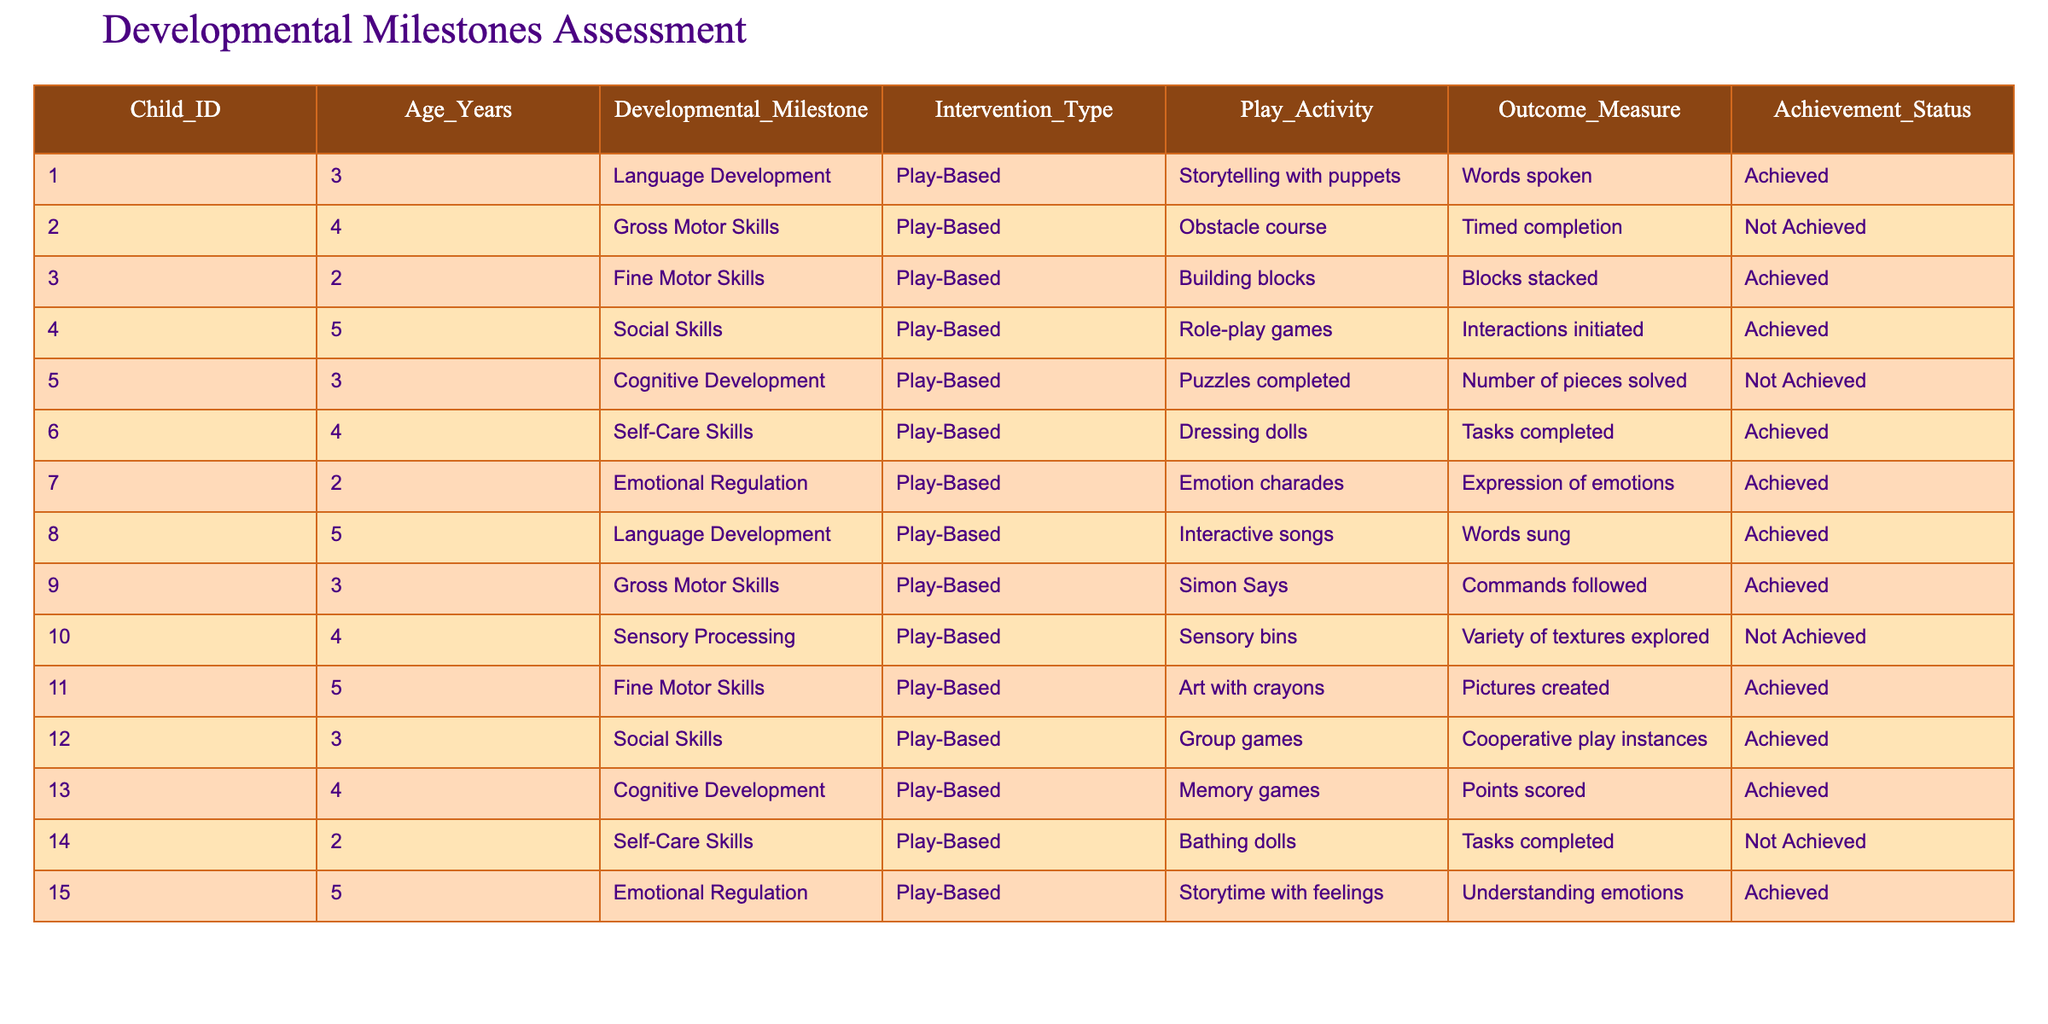What percentage of children achieved their developmental milestones? There are 15 children in the data, out of which 9 achieved their milestones. To find the percentage: (9/15) * 100 = 60%.
Answer: 60% Which age group had the highest number of children achieving their milestones? The age group of 5 years had the most achieved milestones: Children 004, 008, 011, and 015, totaling 4 achievements. Other age groups had fewer: 3 years (5 achievements), 4 years (3 achievements), and 2 years (2 achievements).
Answer: 5 years What is the outcome measure for the play activity "Building blocks"? The outcome measure for "Building blocks" under Fine Motor Skills is "Blocks stacked".
Answer: Blocks stacked Did any child not achieve their milestone in gross motor skills? Yes, child 002 did not achieve their milestone in gross motor skills, as indicated by "Not Achieved" in the Achievement Status column.
Answer: Yes How many different types of interventions were used across all children? There was only one type of intervention used, which is "Play-Based".
Answer: 1 Is there a child who has achieved both language and social skills? Yes, child 004 achieved social skills while child 008 achieved language development, but there is no single child achieving both.
Answer: No Which intervention type was used for the highest number of children who achieved their milestones? The "Play-Based" intervention type was used for all children, and among those, 9 children achieved their milestones.
Answer: Play-Based What specific play activity was used for the child who struggled with cognitive development? The play activity used for child 005 who struggled with cognitive development was "Puzzles completed".
Answer: Puzzles completed How many total achievements were recorded for emotional regulation across all ages? There were 2 achievements for emotional regulation: child 007 and child 015. So, the total achievements for emotional regulation is 2.
Answer: 2 What is the difference in achievement status between the age groups 2 years and 5 years? There are 2 children in the 2-year age group, both achieved their goals, while there are 4 children in the 5-year age group, with 4 achievements. Therefore, both age groups show success, but 5-year-olds have more data points.
Answer: 5 years has more data points achieving success 